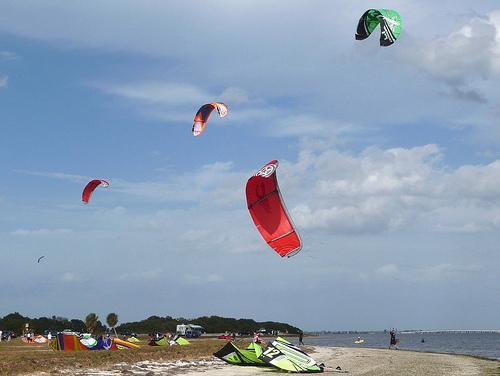Is it raining?
Short answer required. No. What are the things on air?
Answer briefly. Kites. Which kite is closest to the photographer?
Short answer required. Red one. Where is this scene?
Short answer required. Beach. 